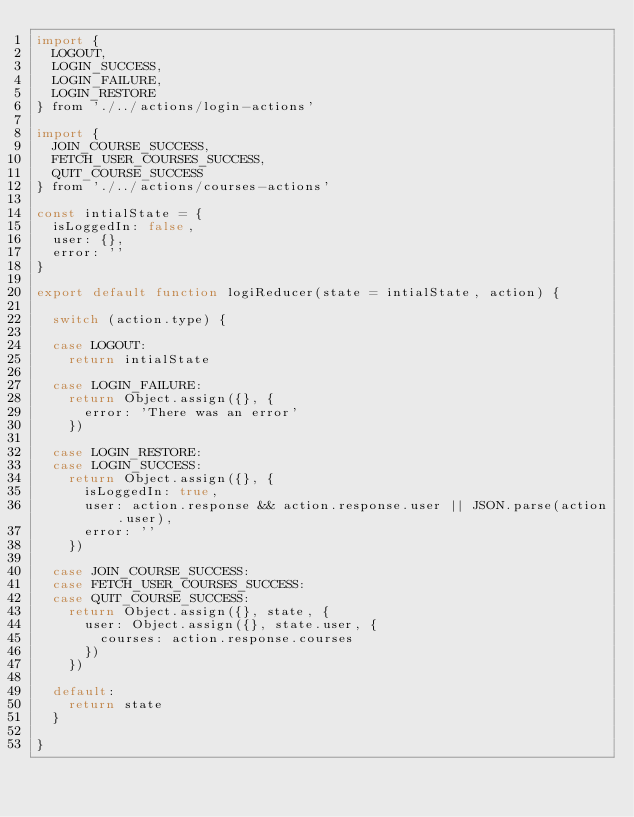<code> <loc_0><loc_0><loc_500><loc_500><_JavaScript_>import {
  LOGOUT,
  LOGIN_SUCCESS,
  LOGIN_FAILURE,
  LOGIN_RESTORE
} from './../actions/login-actions'

import {
  JOIN_COURSE_SUCCESS,
  FETCH_USER_COURSES_SUCCESS,
  QUIT_COURSE_SUCCESS
} from './../actions/courses-actions'

const intialState = {
  isLoggedIn: false,
  user: {},
  error: ''
}

export default function logiReducer(state = intialState, action) {

  switch (action.type) {

  case LOGOUT:
    return intialState

  case LOGIN_FAILURE:
    return Object.assign({}, {
      error: 'There was an error'
    })

  case LOGIN_RESTORE:
  case LOGIN_SUCCESS:
    return Object.assign({}, {
      isLoggedIn: true,
      user: action.response && action.response.user || JSON.parse(action.user),
      error: ''
    })

  case JOIN_COURSE_SUCCESS:
  case FETCH_USER_COURSES_SUCCESS:
  case QUIT_COURSE_SUCCESS:
    return Object.assign({}, state, {
      user: Object.assign({}, state.user, {
        courses: action.response.courses
      })
    })

  default:
    return state
  }

}
</code> 